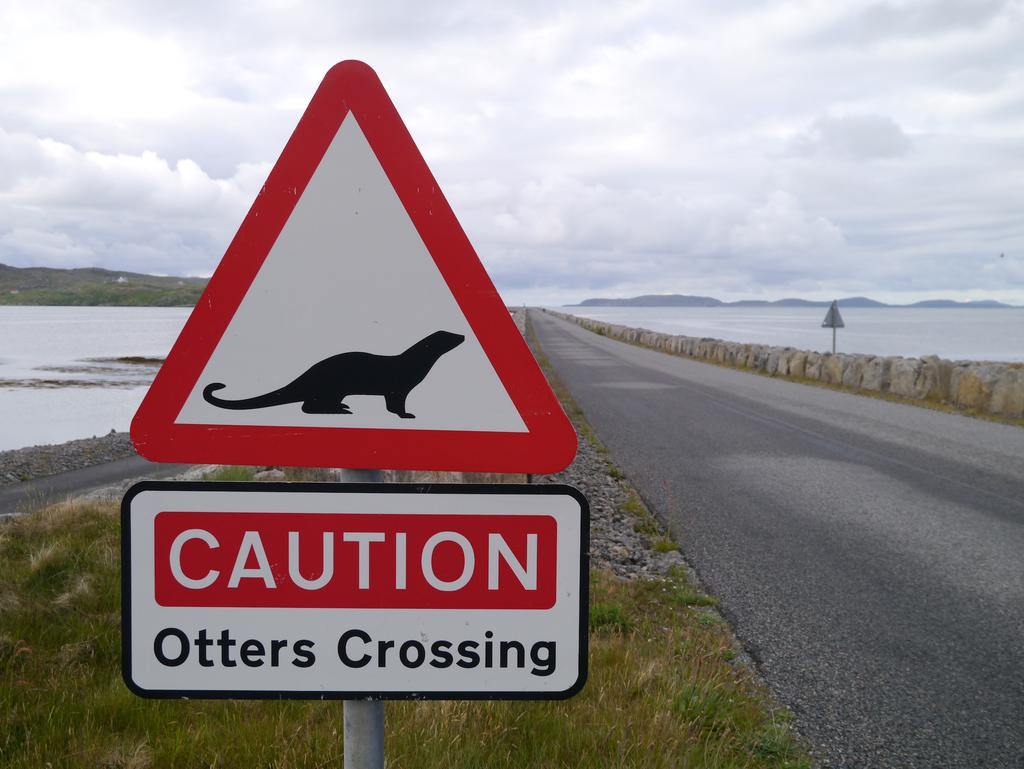<image>
Relay a brief, clear account of the picture shown. A street sign near two bodies of water with a picture of an otter with another sign below it that says Caution Otters Crossing. 